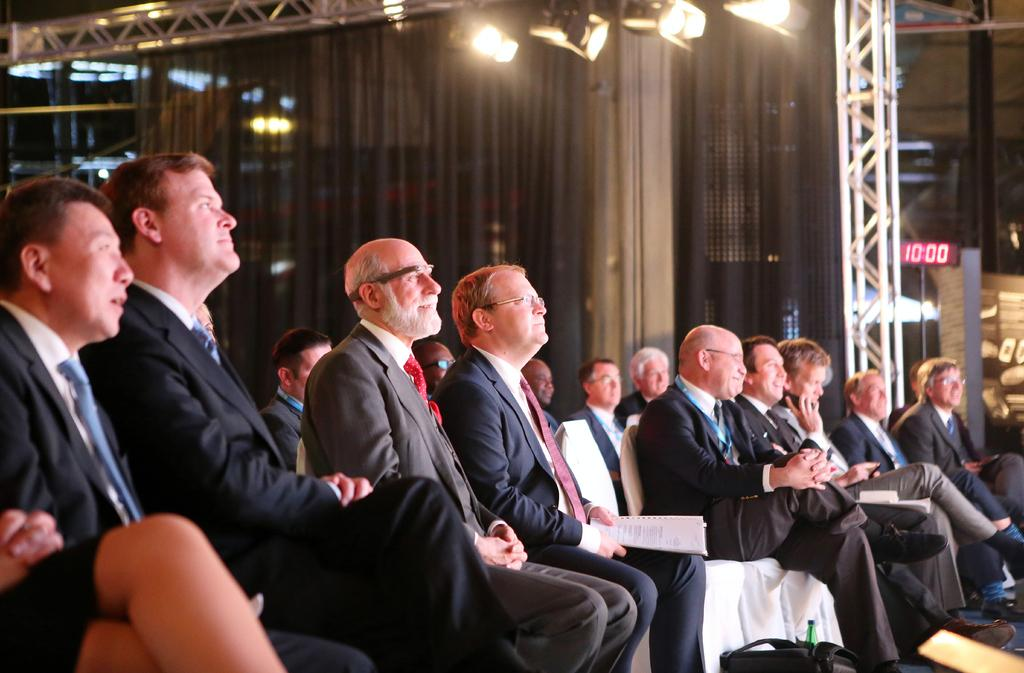What objects are in the foreground of the image? There are chairs, people, and bags in the foreground of the image. What can be seen in the background of the image? There is a curtain in the background of the image. What is located on the roof at the top of the image? There are lights on the roof at the top of the image. What type of deer can be seen learning from its error in the image? There is no deer present in the image, and therefore no such learning or error can be observed. 